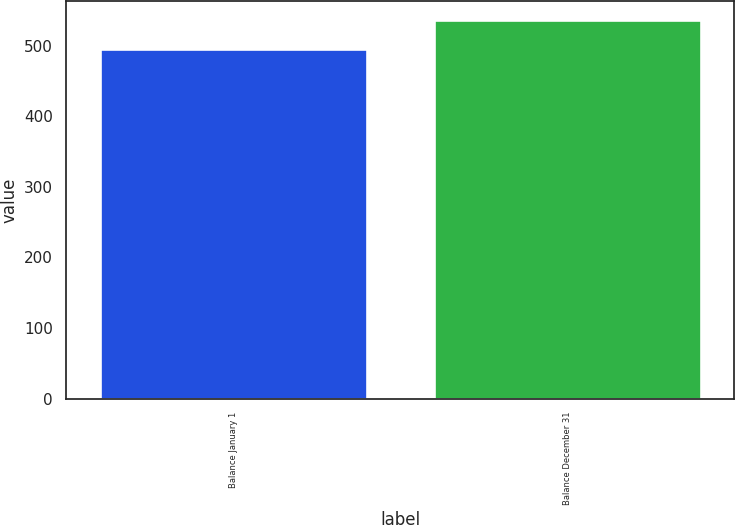Convert chart to OTSL. <chart><loc_0><loc_0><loc_500><loc_500><bar_chart><fcel>Balance January 1<fcel>Balance December 31<nl><fcel>495<fcel>536<nl></chart> 